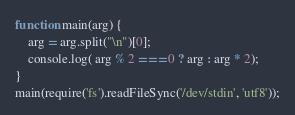<code> <loc_0><loc_0><loc_500><loc_500><_JavaScript_>function main(arg) {
    arg = arg.split("\n")[0];
    console.log( arg % 2 === 0 ? arg : arg * 2);
}
main(require('fs').readFileSync('/dev/stdin', 'utf8'));</code> 